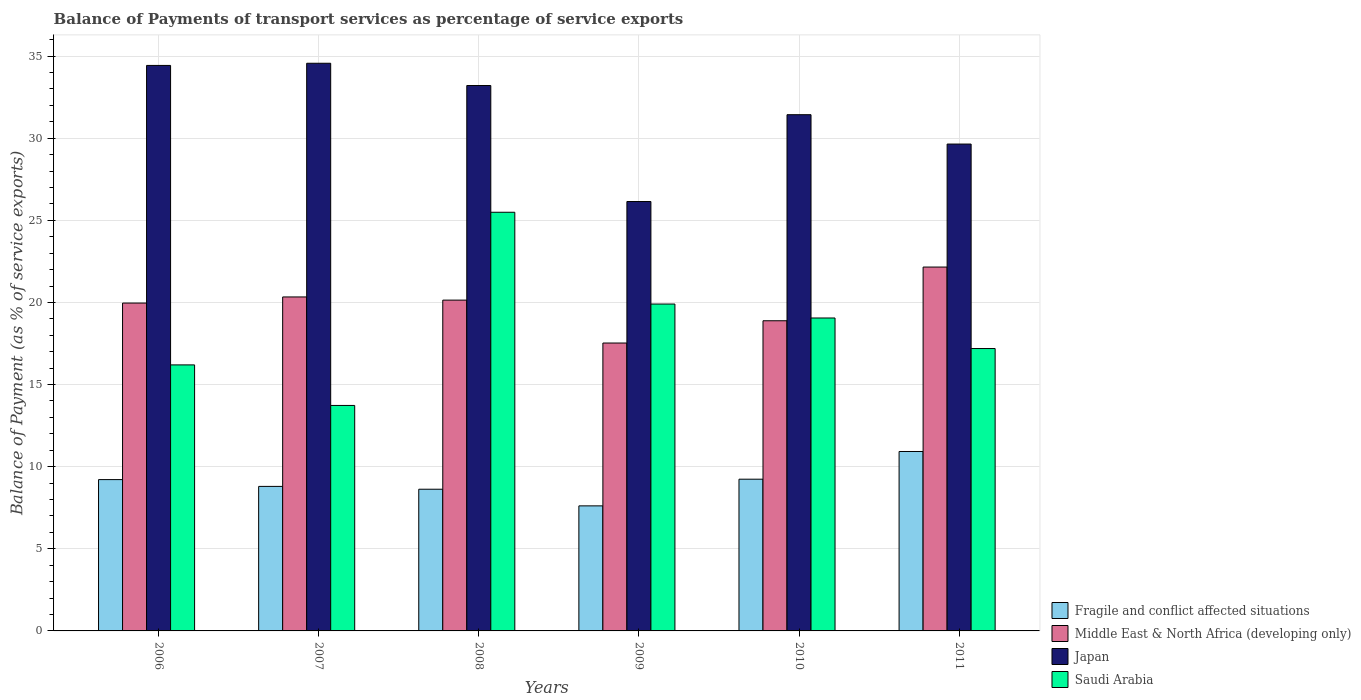How many groups of bars are there?
Offer a very short reply. 6. Are the number of bars per tick equal to the number of legend labels?
Ensure brevity in your answer.  Yes. How many bars are there on the 2nd tick from the right?
Offer a terse response. 4. What is the balance of payments of transport services in Saudi Arabia in 2007?
Your answer should be very brief. 13.73. Across all years, what is the maximum balance of payments of transport services in Japan?
Your answer should be compact. 34.56. Across all years, what is the minimum balance of payments of transport services in Fragile and conflict affected situations?
Your answer should be compact. 7.61. In which year was the balance of payments of transport services in Middle East & North Africa (developing only) minimum?
Offer a very short reply. 2009. What is the total balance of payments of transport services in Middle East & North Africa (developing only) in the graph?
Keep it short and to the point. 119. What is the difference between the balance of payments of transport services in Fragile and conflict affected situations in 2009 and that in 2010?
Keep it short and to the point. -1.62. What is the difference between the balance of payments of transport services in Saudi Arabia in 2011 and the balance of payments of transport services in Fragile and conflict affected situations in 2006?
Make the answer very short. 7.98. What is the average balance of payments of transport services in Saudi Arabia per year?
Keep it short and to the point. 18.59. In the year 2011, what is the difference between the balance of payments of transport services in Middle East & North Africa (developing only) and balance of payments of transport services in Japan?
Your answer should be very brief. -7.49. In how many years, is the balance of payments of transport services in Middle East & North Africa (developing only) greater than 35 %?
Provide a short and direct response. 0. What is the ratio of the balance of payments of transport services in Middle East & North Africa (developing only) in 2007 to that in 2009?
Your response must be concise. 1.16. Is the difference between the balance of payments of transport services in Middle East & North Africa (developing only) in 2006 and 2009 greater than the difference between the balance of payments of transport services in Japan in 2006 and 2009?
Your answer should be very brief. No. What is the difference between the highest and the second highest balance of payments of transport services in Fragile and conflict affected situations?
Give a very brief answer. 1.69. What is the difference between the highest and the lowest balance of payments of transport services in Saudi Arabia?
Ensure brevity in your answer.  11.76. In how many years, is the balance of payments of transport services in Fragile and conflict affected situations greater than the average balance of payments of transport services in Fragile and conflict affected situations taken over all years?
Your answer should be very brief. 3. Is the sum of the balance of payments of transport services in Middle East & North Africa (developing only) in 2007 and 2008 greater than the maximum balance of payments of transport services in Saudi Arabia across all years?
Offer a terse response. Yes. What does the 1st bar from the right in 2010 represents?
Offer a terse response. Saudi Arabia. Is it the case that in every year, the sum of the balance of payments of transport services in Saudi Arabia and balance of payments of transport services in Middle East & North Africa (developing only) is greater than the balance of payments of transport services in Fragile and conflict affected situations?
Provide a succinct answer. Yes. How many bars are there?
Your answer should be compact. 24. Are all the bars in the graph horizontal?
Keep it short and to the point. No. What is the difference between two consecutive major ticks on the Y-axis?
Your response must be concise. 5. Does the graph contain grids?
Provide a succinct answer. Yes. How many legend labels are there?
Give a very brief answer. 4. What is the title of the graph?
Offer a very short reply. Balance of Payments of transport services as percentage of service exports. What is the label or title of the Y-axis?
Ensure brevity in your answer.  Balance of Payment (as % of service exports). What is the Balance of Payment (as % of service exports) of Fragile and conflict affected situations in 2006?
Your answer should be compact. 9.21. What is the Balance of Payment (as % of service exports) of Middle East & North Africa (developing only) in 2006?
Your answer should be compact. 19.96. What is the Balance of Payment (as % of service exports) of Japan in 2006?
Your answer should be compact. 34.43. What is the Balance of Payment (as % of service exports) of Saudi Arabia in 2006?
Make the answer very short. 16.2. What is the Balance of Payment (as % of service exports) of Fragile and conflict affected situations in 2007?
Provide a succinct answer. 8.8. What is the Balance of Payment (as % of service exports) in Middle East & North Africa (developing only) in 2007?
Your answer should be very brief. 20.33. What is the Balance of Payment (as % of service exports) of Japan in 2007?
Provide a short and direct response. 34.56. What is the Balance of Payment (as % of service exports) of Saudi Arabia in 2007?
Offer a terse response. 13.73. What is the Balance of Payment (as % of service exports) of Fragile and conflict affected situations in 2008?
Your response must be concise. 8.63. What is the Balance of Payment (as % of service exports) in Middle East & North Africa (developing only) in 2008?
Ensure brevity in your answer.  20.14. What is the Balance of Payment (as % of service exports) in Japan in 2008?
Provide a short and direct response. 33.21. What is the Balance of Payment (as % of service exports) of Saudi Arabia in 2008?
Offer a very short reply. 25.49. What is the Balance of Payment (as % of service exports) in Fragile and conflict affected situations in 2009?
Keep it short and to the point. 7.61. What is the Balance of Payment (as % of service exports) in Middle East & North Africa (developing only) in 2009?
Your answer should be very brief. 17.53. What is the Balance of Payment (as % of service exports) of Japan in 2009?
Your response must be concise. 26.14. What is the Balance of Payment (as % of service exports) of Saudi Arabia in 2009?
Your response must be concise. 19.9. What is the Balance of Payment (as % of service exports) of Fragile and conflict affected situations in 2010?
Keep it short and to the point. 9.24. What is the Balance of Payment (as % of service exports) of Middle East & North Africa (developing only) in 2010?
Make the answer very short. 18.88. What is the Balance of Payment (as % of service exports) in Japan in 2010?
Offer a terse response. 31.43. What is the Balance of Payment (as % of service exports) of Saudi Arabia in 2010?
Provide a short and direct response. 19.05. What is the Balance of Payment (as % of service exports) in Fragile and conflict affected situations in 2011?
Ensure brevity in your answer.  10.92. What is the Balance of Payment (as % of service exports) in Middle East & North Africa (developing only) in 2011?
Ensure brevity in your answer.  22.15. What is the Balance of Payment (as % of service exports) in Japan in 2011?
Ensure brevity in your answer.  29.64. What is the Balance of Payment (as % of service exports) of Saudi Arabia in 2011?
Offer a terse response. 17.19. Across all years, what is the maximum Balance of Payment (as % of service exports) of Fragile and conflict affected situations?
Your answer should be compact. 10.92. Across all years, what is the maximum Balance of Payment (as % of service exports) of Middle East & North Africa (developing only)?
Keep it short and to the point. 22.15. Across all years, what is the maximum Balance of Payment (as % of service exports) in Japan?
Your answer should be very brief. 34.56. Across all years, what is the maximum Balance of Payment (as % of service exports) of Saudi Arabia?
Offer a terse response. 25.49. Across all years, what is the minimum Balance of Payment (as % of service exports) in Fragile and conflict affected situations?
Make the answer very short. 7.61. Across all years, what is the minimum Balance of Payment (as % of service exports) in Middle East & North Africa (developing only)?
Provide a short and direct response. 17.53. Across all years, what is the minimum Balance of Payment (as % of service exports) in Japan?
Your response must be concise. 26.14. Across all years, what is the minimum Balance of Payment (as % of service exports) of Saudi Arabia?
Your answer should be very brief. 13.73. What is the total Balance of Payment (as % of service exports) in Fragile and conflict affected situations in the graph?
Your answer should be compact. 54.42. What is the total Balance of Payment (as % of service exports) of Middle East & North Africa (developing only) in the graph?
Your answer should be compact. 119. What is the total Balance of Payment (as % of service exports) of Japan in the graph?
Your answer should be compact. 189.42. What is the total Balance of Payment (as % of service exports) in Saudi Arabia in the graph?
Your answer should be very brief. 111.56. What is the difference between the Balance of Payment (as % of service exports) in Fragile and conflict affected situations in 2006 and that in 2007?
Your response must be concise. 0.41. What is the difference between the Balance of Payment (as % of service exports) in Middle East & North Africa (developing only) in 2006 and that in 2007?
Keep it short and to the point. -0.37. What is the difference between the Balance of Payment (as % of service exports) of Japan in 2006 and that in 2007?
Provide a short and direct response. -0.13. What is the difference between the Balance of Payment (as % of service exports) of Saudi Arabia in 2006 and that in 2007?
Your answer should be compact. 2.47. What is the difference between the Balance of Payment (as % of service exports) in Fragile and conflict affected situations in 2006 and that in 2008?
Your answer should be very brief. 0.59. What is the difference between the Balance of Payment (as % of service exports) of Middle East & North Africa (developing only) in 2006 and that in 2008?
Make the answer very short. -0.18. What is the difference between the Balance of Payment (as % of service exports) of Japan in 2006 and that in 2008?
Your answer should be compact. 1.22. What is the difference between the Balance of Payment (as % of service exports) in Saudi Arabia in 2006 and that in 2008?
Make the answer very short. -9.29. What is the difference between the Balance of Payment (as % of service exports) of Fragile and conflict affected situations in 2006 and that in 2009?
Provide a short and direct response. 1.6. What is the difference between the Balance of Payment (as % of service exports) in Middle East & North Africa (developing only) in 2006 and that in 2009?
Your answer should be compact. 2.43. What is the difference between the Balance of Payment (as % of service exports) in Japan in 2006 and that in 2009?
Provide a short and direct response. 8.29. What is the difference between the Balance of Payment (as % of service exports) in Saudi Arabia in 2006 and that in 2009?
Provide a succinct answer. -3.71. What is the difference between the Balance of Payment (as % of service exports) of Fragile and conflict affected situations in 2006 and that in 2010?
Keep it short and to the point. -0.02. What is the difference between the Balance of Payment (as % of service exports) in Middle East & North Africa (developing only) in 2006 and that in 2010?
Offer a terse response. 1.08. What is the difference between the Balance of Payment (as % of service exports) of Japan in 2006 and that in 2010?
Keep it short and to the point. 3. What is the difference between the Balance of Payment (as % of service exports) of Saudi Arabia in 2006 and that in 2010?
Give a very brief answer. -2.86. What is the difference between the Balance of Payment (as % of service exports) of Fragile and conflict affected situations in 2006 and that in 2011?
Keep it short and to the point. -1.71. What is the difference between the Balance of Payment (as % of service exports) of Middle East & North Africa (developing only) in 2006 and that in 2011?
Make the answer very short. -2.19. What is the difference between the Balance of Payment (as % of service exports) of Japan in 2006 and that in 2011?
Offer a terse response. 4.79. What is the difference between the Balance of Payment (as % of service exports) of Saudi Arabia in 2006 and that in 2011?
Offer a very short reply. -1. What is the difference between the Balance of Payment (as % of service exports) in Fragile and conflict affected situations in 2007 and that in 2008?
Ensure brevity in your answer.  0.17. What is the difference between the Balance of Payment (as % of service exports) in Middle East & North Africa (developing only) in 2007 and that in 2008?
Provide a short and direct response. 0.19. What is the difference between the Balance of Payment (as % of service exports) of Japan in 2007 and that in 2008?
Your response must be concise. 1.36. What is the difference between the Balance of Payment (as % of service exports) in Saudi Arabia in 2007 and that in 2008?
Your answer should be compact. -11.76. What is the difference between the Balance of Payment (as % of service exports) in Fragile and conflict affected situations in 2007 and that in 2009?
Offer a very short reply. 1.19. What is the difference between the Balance of Payment (as % of service exports) of Middle East & North Africa (developing only) in 2007 and that in 2009?
Provide a short and direct response. 2.81. What is the difference between the Balance of Payment (as % of service exports) in Japan in 2007 and that in 2009?
Provide a succinct answer. 8.42. What is the difference between the Balance of Payment (as % of service exports) of Saudi Arabia in 2007 and that in 2009?
Offer a very short reply. -6.17. What is the difference between the Balance of Payment (as % of service exports) of Fragile and conflict affected situations in 2007 and that in 2010?
Your answer should be compact. -0.44. What is the difference between the Balance of Payment (as % of service exports) in Middle East & North Africa (developing only) in 2007 and that in 2010?
Your response must be concise. 1.45. What is the difference between the Balance of Payment (as % of service exports) of Japan in 2007 and that in 2010?
Ensure brevity in your answer.  3.13. What is the difference between the Balance of Payment (as % of service exports) in Saudi Arabia in 2007 and that in 2010?
Your answer should be very brief. -5.33. What is the difference between the Balance of Payment (as % of service exports) of Fragile and conflict affected situations in 2007 and that in 2011?
Your answer should be compact. -2.13. What is the difference between the Balance of Payment (as % of service exports) of Middle East & North Africa (developing only) in 2007 and that in 2011?
Offer a very short reply. -1.82. What is the difference between the Balance of Payment (as % of service exports) of Japan in 2007 and that in 2011?
Your answer should be very brief. 4.92. What is the difference between the Balance of Payment (as % of service exports) of Saudi Arabia in 2007 and that in 2011?
Offer a terse response. -3.46. What is the difference between the Balance of Payment (as % of service exports) in Fragile and conflict affected situations in 2008 and that in 2009?
Keep it short and to the point. 1.01. What is the difference between the Balance of Payment (as % of service exports) of Middle East & North Africa (developing only) in 2008 and that in 2009?
Ensure brevity in your answer.  2.61. What is the difference between the Balance of Payment (as % of service exports) in Japan in 2008 and that in 2009?
Your answer should be compact. 7.06. What is the difference between the Balance of Payment (as % of service exports) in Saudi Arabia in 2008 and that in 2009?
Offer a terse response. 5.59. What is the difference between the Balance of Payment (as % of service exports) in Fragile and conflict affected situations in 2008 and that in 2010?
Offer a very short reply. -0.61. What is the difference between the Balance of Payment (as % of service exports) of Middle East & North Africa (developing only) in 2008 and that in 2010?
Offer a very short reply. 1.26. What is the difference between the Balance of Payment (as % of service exports) of Japan in 2008 and that in 2010?
Offer a terse response. 1.78. What is the difference between the Balance of Payment (as % of service exports) in Saudi Arabia in 2008 and that in 2010?
Your answer should be very brief. 6.44. What is the difference between the Balance of Payment (as % of service exports) of Fragile and conflict affected situations in 2008 and that in 2011?
Keep it short and to the point. -2.3. What is the difference between the Balance of Payment (as % of service exports) of Middle East & North Africa (developing only) in 2008 and that in 2011?
Keep it short and to the point. -2.01. What is the difference between the Balance of Payment (as % of service exports) in Japan in 2008 and that in 2011?
Ensure brevity in your answer.  3.56. What is the difference between the Balance of Payment (as % of service exports) of Saudi Arabia in 2008 and that in 2011?
Your response must be concise. 8.3. What is the difference between the Balance of Payment (as % of service exports) of Fragile and conflict affected situations in 2009 and that in 2010?
Your answer should be very brief. -1.62. What is the difference between the Balance of Payment (as % of service exports) of Middle East & North Africa (developing only) in 2009 and that in 2010?
Your answer should be compact. -1.36. What is the difference between the Balance of Payment (as % of service exports) of Japan in 2009 and that in 2010?
Provide a short and direct response. -5.29. What is the difference between the Balance of Payment (as % of service exports) in Saudi Arabia in 2009 and that in 2010?
Your response must be concise. 0.85. What is the difference between the Balance of Payment (as % of service exports) of Fragile and conflict affected situations in 2009 and that in 2011?
Give a very brief answer. -3.31. What is the difference between the Balance of Payment (as % of service exports) in Middle East & North Africa (developing only) in 2009 and that in 2011?
Offer a very short reply. -4.63. What is the difference between the Balance of Payment (as % of service exports) in Japan in 2009 and that in 2011?
Your answer should be very brief. -3.5. What is the difference between the Balance of Payment (as % of service exports) in Saudi Arabia in 2009 and that in 2011?
Provide a short and direct response. 2.71. What is the difference between the Balance of Payment (as % of service exports) of Fragile and conflict affected situations in 2010 and that in 2011?
Keep it short and to the point. -1.69. What is the difference between the Balance of Payment (as % of service exports) of Middle East & North Africa (developing only) in 2010 and that in 2011?
Provide a short and direct response. -3.27. What is the difference between the Balance of Payment (as % of service exports) of Japan in 2010 and that in 2011?
Provide a succinct answer. 1.79. What is the difference between the Balance of Payment (as % of service exports) in Saudi Arabia in 2010 and that in 2011?
Provide a short and direct response. 1.86. What is the difference between the Balance of Payment (as % of service exports) in Fragile and conflict affected situations in 2006 and the Balance of Payment (as % of service exports) in Middle East & North Africa (developing only) in 2007?
Give a very brief answer. -11.12. What is the difference between the Balance of Payment (as % of service exports) in Fragile and conflict affected situations in 2006 and the Balance of Payment (as % of service exports) in Japan in 2007?
Make the answer very short. -25.35. What is the difference between the Balance of Payment (as % of service exports) in Fragile and conflict affected situations in 2006 and the Balance of Payment (as % of service exports) in Saudi Arabia in 2007?
Provide a short and direct response. -4.51. What is the difference between the Balance of Payment (as % of service exports) in Middle East & North Africa (developing only) in 2006 and the Balance of Payment (as % of service exports) in Japan in 2007?
Provide a succinct answer. -14.6. What is the difference between the Balance of Payment (as % of service exports) of Middle East & North Africa (developing only) in 2006 and the Balance of Payment (as % of service exports) of Saudi Arabia in 2007?
Keep it short and to the point. 6.23. What is the difference between the Balance of Payment (as % of service exports) in Japan in 2006 and the Balance of Payment (as % of service exports) in Saudi Arabia in 2007?
Make the answer very short. 20.7. What is the difference between the Balance of Payment (as % of service exports) in Fragile and conflict affected situations in 2006 and the Balance of Payment (as % of service exports) in Middle East & North Africa (developing only) in 2008?
Provide a succinct answer. -10.93. What is the difference between the Balance of Payment (as % of service exports) in Fragile and conflict affected situations in 2006 and the Balance of Payment (as % of service exports) in Japan in 2008?
Offer a terse response. -23.99. What is the difference between the Balance of Payment (as % of service exports) of Fragile and conflict affected situations in 2006 and the Balance of Payment (as % of service exports) of Saudi Arabia in 2008?
Offer a terse response. -16.28. What is the difference between the Balance of Payment (as % of service exports) of Middle East & North Africa (developing only) in 2006 and the Balance of Payment (as % of service exports) of Japan in 2008?
Your answer should be compact. -13.24. What is the difference between the Balance of Payment (as % of service exports) in Middle East & North Africa (developing only) in 2006 and the Balance of Payment (as % of service exports) in Saudi Arabia in 2008?
Keep it short and to the point. -5.53. What is the difference between the Balance of Payment (as % of service exports) of Japan in 2006 and the Balance of Payment (as % of service exports) of Saudi Arabia in 2008?
Provide a short and direct response. 8.94. What is the difference between the Balance of Payment (as % of service exports) in Fragile and conflict affected situations in 2006 and the Balance of Payment (as % of service exports) in Middle East & North Africa (developing only) in 2009?
Offer a terse response. -8.32. What is the difference between the Balance of Payment (as % of service exports) of Fragile and conflict affected situations in 2006 and the Balance of Payment (as % of service exports) of Japan in 2009?
Make the answer very short. -16.93. What is the difference between the Balance of Payment (as % of service exports) of Fragile and conflict affected situations in 2006 and the Balance of Payment (as % of service exports) of Saudi Arabia in 2009?
Offer a terse response. -10.69. What is the difference between the Balance of Payment (as % of service exports) of Middle East & North Africa (developing only) in 2006 and the Balance of Payment (as % of service exports) of Japan in 2009?
Your answer should be compact. -6.18. What is the difference between the Balance of Payment (as % of service exports) in Middle East & North Africa (developing only) in 2006 and the Balance of Payment (as % of service exports) in Saudi Arabia in 2009?
Your response must be concise. 0.06. What is the difference between the Balance of Payment (as % of service exports) in Japan in 2006 and the Balance of Payment (as % of service exports) in Saudi Arabia in 2009?
Ensure brevity in your answer.  14.53. What is the difference between the Balance of Payment (as % of service exports) in Fragile and conflict affected situations in 2006 and the Balance of Payment (as % of service exports) in Middle East & North Africa (developing only) in 2010?
Ensure brevity in your answer.  -9.67. What is the difference between the Balance of Payment (as % of service exports) in Fragile and conflict affected situations in 2006 and the Balance of Payment (as % of service exports) in Japan in 2010?
Offer a very short reply. -22.22. What is the difference between the Balance of Payment (as % of service exports) of Fragile and conflict affected situations in 2006 and the Balance of Payment (as % of service exports) of Saudi Arabia in 2010?
Make the answer very short. -9.84. What is the difference between the Balance of Payment (as % of service exports) in Middle East & North Africa (developing only) in 2006 and the Balance of Payment (as % of service exports) in Japan in 2010?
Offer a very short reply. -11.47. What is the difference between the Balance of Payment (as % of service exports) in Japan in 2006 and the Balance of Payment (as % of service exports) in Saudi Arabia in 2010?
Keep it short and to the point. 15.38. What is the difference between the Balance of Payment (as % of service exports) of Fragile and conflict affected situations in 2006 and the Balance of Payment (as % of service exports) of Middle East & North Africa (developing only) in 2011?
Make the answer very short. -12.94. What is the difference between the Balance of Payment (as % of service exports) of Fragile and conflict affected situations in 2006 and the Balance of Payment (as % of service exports) of Japan in 2011?
Offer a terse response. -20.43. What is the difference between the Balance of Payment (as % of service exports) of Fragile and conflict affected situations in 2006 and the Balance of Payment (as % of service exports) of Saudi Arabia in 2011?
Provide a succinct answer. -7.98. What is the difference between the Balance of Payment (as % of service exports) of Middle East & North Africa (developing only) in 2006 and the Balance of Payment (as % of service exports) of Japan in 2011?
Make the answer very short. -9.68. What is the difference between the Balance of Payment (as % of service exports) of Middle East & North Africa (developing only) in 2006 and the Balance of Payment (as % of service exports) of Saudi Arabia in 2011?
Offer a very short reply. 2.77. What is the difference between the Balance of Payment (as % of service exports) of Japan in 2006 and the Balance of Payment (as % of service exports) of Saudi Arabia in 2011?
Your answer should be very brief. 17.24. What is the difference between the Balance of Payment (as % of service exports) of Fragile and conflict affected situations in 2007 and the Balance of Payment (as % of service exports) of Middle East & North Africa (developing only) in 2008?
Your response must be concise. -11.34. What is the difference between the Balance of Payment (as % of service exports) of Fragile and conflict affected situations in 2007 and the Balance of Payment (as % of service exports) of Japan in 2008?
Offer a very short reply. -24.41. What is the difference between the Balance of Payment (as % of service exports) in Fragile and conflict affected situations in 2007 and the Balance of Payment (as % of service exports) in Saudi Arabia in 2008?
Provide a succinct answer. -16.69. What is the difference between the Balance of Payment (as % of service exports) of Middle East & North Africa (developing only) in 2007 and the Balance of Payment (as % of service exports) of Japan in 2008?
Make the answer very short. -12.87. What is the difference between the Balance of Payment (as % of service exports) in Middle East & North Africa (developing only) in 2007 and the Balance of Payment (as % of service exports) in Saudi Arabia in 2008?
Provide a short and direct response. -5.16. What is the difference between the Balance of Payment (as % of service exports) of Japan in 2007 and the Balance of Payment (as % of service exports) of Saudi Arabia in 2008?
Your answer should be very brief. 9.07. What is the difference between the Balance of Payment (as % of service exports) in Fragile and conflict affected situations in 2007 and the Balance of Payment (as % of service exports) in Middle East & North Africa (developing only) in 2009?
Your response must be concise. -8.73. What is the difference between the Balance of Payment (as % of service exports) in Fragile and conflict affected situations in 2007 and the Balance of Payment (as % of service exports) in Japan in 2009?
Offer a very short reply. -17.34. What is the difference between the Balance of Payment (as % of service exports) of Fragile and conflict affected situations in 2007 and the Balance of Payment (as % of service exports) of Saudi Arabia in 2009?
Your answer should be compact. -11.1. What is the difference between the Balance of Payment (as % of service exports) in Middle East & North Africa (developing only) in 2007 and the Balance of Payment (as % of service exports) in Japan in 2009?
Your answer should be compact. -5.81. What is the difference between the Balance of Payment (as % of service exports) of Middle East & North Africa (developing only) in 2007 and the Balance of Payment (as % of service exports) of Saudi Arabia in 2009?
Your answer should be very brief. 0.43. What is the difference between the Balance of Payment (as % of service exports) of Japan in 2007 and the Balance of Payment (as % of service exports) of Saudi Arabia in 2009?
Your answer should be very brief. 14.66. What is the difference between the Balance of Payment (as % of service exports) of Fragile and conflict affected situations in 2007 and the Balance of Payment (as % of service exports) of Middle East & North Africa (developing only) in 2010?
Make the answer very short. -10.09. What is the difference between the Balance of Payment (as % of service exports) of Fragile and conflict affected situations in 2007 and the Balance of Payment (as % of service exports) of Japan in 2010?
Give a very brief answer. -22.63. What is the difference between the Balance of Payment (as % of service exports) in Fragile and conflict affected situations in 2007 and the Balance of Payment (as % of service exports) in Saudi Arabia in 2010?
Offer a very short reply. -10.25. What is the difference between the Balance of Payment (as % of service exports) of Middle East & North Africa (developing only) in 2007 and the Balance of Payment (as % of service exports) of Japan in 2010?
Your answer should be compact. -11.1. What is the difference between the Balance of Payment (as % of service exports) of Middle East & North Africa (developing only) in 2007 and the Balance of Payment (as % of service exports) of Saudi Arabia in 2010?
Keep it short and to the point. 1.28. What is the difference between the Balance of Payment (as % of service exports) of Japan in 2007 and the Balance of Payment (as % of service exports) of Saudi Arabia in 2010?
Your answer should be very brief. 15.51. What is the difference between the Balance of Payment (as % of service exports) in Fragile and conflict affected situations in 2007 and the Balance of Payment (as % of service exports) in Middle East & North Africa (developing only) in 2011?
Your response must be concise. -13.36. What is the difference between the Balance of Payment (as % of service exports) in Fragile and conflict affected situations in 2007 and the Balance of Payment (as % of service exports) in Japan in 2011?
Provide a short and direct response. -20.84. What is the difference between the Balance of Payment (as % of service exports) of Fragile and conflict affected situations in 2007 and the Balance of Payment (as % of service exports) of Saudi Arabia in 2011?
Ensure brevity in your answer.  -8.39. What is the difference between the Balance of Payment (as % of service exports) of Middle East & North Africa (developing only) in 2007 and the Balance of Payment (as % of service exports) of Japan in 2011?
Provide a succinct answer. -9.31. What is the difference between the Balance of Payment (as % of service exports) in Middle East & North Africa (developing only) in 2007 and the Balance of Payment (as % of service exports) in Saudi Arabia in 2011?
Your answer should be compact. 3.14. What is the difference between the Balance of Payment (as % of service exports) in Japan in 2007 and the Balance of Payment (as % of service exports) in Saudi Arabia in 2011?
Your response must be concise. 17.37. What is the difference between the Balance of Payment (as % of service exports) in Fragile and conflict affected situations in 2008 and the Balance of Payment (as % of service exports) in Middle East & North Africa (developing only) in 2009?
Your answer should be compact. -8.9. What is the difference between the Balance of Payment (as % of service exports) of Fragile and conflict affected situations in 2008 and the Balance of Payment (as % of service exports) of Japan in 2009?
Keep it short and to the point. -17.52. What is the difference between the Balance of Payment (as % of service exports) of Fragile and conflict affected situations in 2008 and the Balance of Payment (as % of service exports) of Saudi Arabia in 2009?
Your answer should be compact. -11.27. What is the difference between the Balance of Payment (as % of service exports) of Middle East & North Africa (developing only) in 2008 and the Balance of Payment (as % of service exports) of Japan in 2009?
Make the answer very short. -6. What is the difference between the Balance of Payment (as % of service exports) in Middle East & North Africa (developing only) in 2008 and the Balance of Payment (as % of service exports) in Saudi Arabia in 2009?
Give a very brief answer. 0.24. What is the difference between the Balance of Payment (as % of service exports) of Japan in 2008 and the Balance of Payment (as % of service exports) of Saudi Arabia in 2009?
Your answer should be very brief. 13.3. What is the difference between the Balance of Payment (as % of service exports) of Fragile and conflict affected situations in 2008 and the Balance of Payment (as % of service exports) of Middle East & North Africa (developing only) in 2010?
Keep it short and to the point. -10.26. What is the difference between the Balance of Payment (as % of service exports) in Fragile and conflict affected situations in 2008 and the Balance of Payment (as % of service exports) in Japan in 2010?
Keep it short and to the point. -22.8. What is the difference between the Balance of Payment (as % of service exports) in Fragile and conflict affected situations in 2008 and the Balance of Payment (as % of service exports) in Saudi Arabia in 2010?
Provide a succinct answer. -10.43. What is the difference between the Balance of Payment (as % of service exports) of Middle East & North Africa (developing only) in 2008 and the Balance of Payment (as % of service exports) of Japan in 2010?
Your answer should be compact. -11.29. What is the difference between the Balance of Payment (as % of service exports) of Middle East & North Africa (developing only) in 2008 and the Balance of Payment (as % of service exports) of Saudi Arabia in 2010?
Keep it short and to the point. 1.09. What is the difference between the Balance of Payment (as % of service exports) in Japan in 2008 and the Balance of Payment (as % of service exports) in Saudi Arabia in 2010?
Offer a terse response. 14.15. What is the difference between the Balance of Payment (as % of service exports) in Fragile and conflict affected situations in 2008 and the Balance of Payment (as % of service exports) in Middle East & North Africa (developing only) in 2011?
Provide a short and direct response. -13.53. What is the difference between the Balance of Payment (as % of service exports) of Fragile and conflict affected situations in 2008 and the Balance of Payment (as % of service exports) of Japan in 2011?
Your answer should be compact. -21.02. What is the difference between the Balance of Payment (as % of service exports) in Fragile and conflict affected situations in 2008 and the Balance of Payment (as % of service exports) in Saudi Arabia in 2011?
Provide a short and direct response. -8.56. What is the difference between the Balance of Payment (as % of service exports) of Middle East & North Africa (developing only) in 2008 and the Balance of Payment (as % of service exports) of Japan in 2011?
Offer a terse response. -9.5. What is the difference between the Balance of Payment (as % of service exports) of Middle East & North Africa (developing only) in 2008 and the Balance of Payment (as % of service exports) of Saudi Arabia in 2011?
Your answer should be very brief. 2.95. What is the difference between the Balance of Payment (as % of service exports) of Japan in 2008 and the Balance of Payment (as % of service exports) of Saudi Arabia in 2011?
Offer a terse response. 16.01. What is the difference between the Balance of Payment (as % of service exports) of Fragile and conflict affected situations in 2009 and the Balance of Payment (as % of service exports) of Middle East & North Africa (developing only) in 2010?
Make the answer very short. -11.27. What is the difference between the Balance of Payment (as % of service exports) in Fragile and conflict affected situations in 2009 and the Balance of Payment (as % of service exports) in Japan in 2010?
Your answer should be compact. -23.82. What is the difference between the Balance of Payment (as % of service exports) in Fragile and conflict affected situations in 2009 and the Balance of Payment (as % of service exports) in Saudi Arabia in 2010?
Your answer should be very brief. -11.44. What is the difference between the Balance of Payment (as % of service exports) in Middle East & North Africa (developing only) in 2009 and the Balance of Payment (as % of service exports) in Japan in 2010?
Offer a very short reply. -13.9. What is the difference between the Balance of Payment (as % of service exports) of Middle East & North Africa (developing only) in 2009 and the Balance of Payment (as % of service exports) of Saudi Arabia in 2010?
Give a very brief answer. -1.52. What is the difference between the Balance of Payment (as % of service exports) in Japan in 2009 and the Balance of Payment (as % of service exports) in Saudi Arabia in 2010?
Your answer should be very brief. 7.09. What is the difference between the Balance of Payment (as % of service exports) in Fragile and conflict affected situations in 2009 and the Balance of Payment (as % of service exports) in Middle East & North Africa (developing only) in 2011?
Your answer should be compact. -14.54. What is the difference between the Balance of Payment (as % of service exports) of Fragile and conflict affected situations in 2009 and the Balance of Payment (as % of service exports) of Japan in 2011?
Make the answer very short. -22.03. What is the difference between the Balance of Payment (as % of service exports) in Fragile and conflict affected situations in 2009 and the Balance of Payment (as % of service exports) in Saudi Arabia in 2011?
Your answer should be compact. -9.58. What is the difference between the Balance of Payment (as % of service exports) in Middle East & North Africa (developing only) in 2009 and the Balance of Payment (as % of service exports) in Japan in 2011?
Keep it short and to the point. -12.11. What is the difference between the Balance of Payment (as % of service exports) in Middle East & North Africa (developing only) in 2009 and the Balance of Payment (as % of service exports) in Saudi Arabia in 2011?
Make the answer very short. 0.34. What is the difference between the Balance of Payment (as % of service exports) of Japan in 2009 and the Balance of Payment (as % of service exports) of Saudi Arabia in 2011?
Provide a succinct answer. 8.95. What is the difference between the Balance of Payment (as % of service exports) of Fragile and conflict affected situations in 2010 and the Balance of Payment (as % of service exports) of Middle East & North Africa (developing only) in 2011?
Give a very brief answer. -12.92. What is the difference between the Balance of Payment (as % of service exports) in Fragile and conflict affected situations in 2010 and the Balance of Payment (as % of service exports) in Japan in 2011?
Your response must be concise. -20.41. What is the difference between the Balance of Payment (as % of service exports) of Fragile and conflict affected situations in 2010 and the Balance of Payment (as % of service exports) of Saudi Arabia in 2011?
Ensure brevity in your answer.  -7.96. What is the difference between the Balance of Payment (as % of service exports) of Middle East & North Africa (developing only) in 2010 and the Balance of Payment (as % of service exports) of Japan in 2011?
Give a very brief answer. -10.76. What is the difference between the Balance of Payment (as % of service exports) of Middle East & North Africa (developing only) in 2010 and the Balance of Payment (as % of service exports) of Saudi Arabia in 2011?
Offer a terse response. 1.69. What is the difference between the Balance of Payment (as % of service exports) in Japan in 2010 and the Balance of Payment (as % of service exports) in Saudi Arabia in 2011?
Offer a terse response. 14.24. What is the average Balance of Payment (as % of service exports) of Fragile and conflict affected situations per year?
Provide a succinct answer. 9.07. What is the average Balance of Payment (as % of service exports) of Middle East & North Africa (developing only) per year?
Provide a short and direct response. 19.83. What is the average Balance of Payment (as % of service exports) of Japan per year?
Keep it short and to the point. 31.57. What is the average Balance of Payment (as % of service exports) in Saudi Arabia per year?
Offer a very short reply. 18.59. In the year 2006, what is the difference between the Balance of Payment (as % of service exports) of Fragile and conflict affected situations and Balance of Payment (as % of service exports) of Middle East & North Africa (developing only)?
Provide a succinct answer. -10.75. In the year 2006, what is the difference between the Balance of Payment (as % of service exports) of Fragile and conflict affected situations and Balance of Payment (as % of service exports) of Japan?
Provide a short and direct response. -25.22. In the year 2006, what is the difference between the Balance of Payment (as % of service exports) of Fragile and conflict affected situations and Balance of Payment (as % of service exports) of Saudi Arabia?
Your response must be concise. -6.98. In the year 2006, what is the difference between the Balance of Payment (as % of service exports) of Middle East & North Africa (developing only) and Balance of Payment (as % of service exports) of Japan?
Your answer should be compact. -14.47. In the year 2006, what is the difference between the Balance of Payment (as % of service exports) in Middle East & North Africa (developing only) and Balance of Payment (as % of service exports) in Saudi Arabia?
Provide a short and direct response. 3.77. In the year 2006, what is the difference between the Balance of Payment (as % of service exports) of Japan and Balance of Payment (as % of service exports) of Saudi Arabia?
Offer a very short reply. 18.23. In the year 2007, what is the difference between the Balance of Payment (as % of service exports) in Fragile and conflict affected situations and Balance of Payment (as % of service exports) in Middle East & North Africa (developing only)?
Offer a terse response. -11.54. In the year 2007, what is the difference between the Balance of Payment (as % of service exports) in Fragile and conflict affected situations and Balance of Payment (as % of service exports) in Japan?
Offer a very short reply. -25.76. In the year 2007, what is the difference between the Balance of Payment (as % of service exports) in Fragile and conflict affected situations and Balance of Payment (as % of service exports) in Saudi Arabia?
Your response must be concise. -4.93. In the year 2007, what is the difference between the Balance of Payment (as % of service exports) in Middle East & North Africa (developing only) and Balance of Payment (as % of service exports) in Japan?
Your response must be concise. -14.23. In the year 2007, what is the difference between the Balance of Payment (as % of service exports) of Middle East & North Africa (developing only) and Balance of Payment (as % of service exports) of Saudi Arabia?
Your response must be concise. 6.61. In the year 2007, what is the difference between the Balance of Payment (as % of service exports) in Japan and Balance of Payment (as % of service exports) in Saudi Arabia?
Offer a very short reply. 20.83. In the year 2008, what is the difference between the Balance of Payment (as % of service exports) in Fragile and conflict affected situations and Balance of Payment (as % of service exports) in Middle East & North Africa (developing only)?
Make the answer very short. -11.51. In the year 2008, what is the difference between the Balance of Payment (as % of service exports) of Fragile and conflict affected situations and Balance of Payment (as % of service exports) of Japan?
Give a very brief answer. -24.58. In the year 2008, what is the difference between the Balance of Payment (as % of service exports) of Fragile and conflict affected situations and Balance of Payment (as % of service exports) of Saudi Arabia?
Ensure brevity in your answer.  -16.86. In the year 2008, what is the difference between the Balance of Payment (as % of service exports) in Middle East & North Africa (developing only) and Balance of Payment (as % of service exports) in Japan?
Offer a very short reply. -13.07. In the year 2008, what is the difference between the Balance of Payment (as % of service exports) of Middle East & North Africa (developing only) and Balance of Payment (as % of service exports) of Saudi Arabia?
Give a very brief answer. -5.35. In the year 2008, what is the difference between the Balance of Payment (as % of service exports) in Japan and Balance of Payment (as % of service exports) in Saudi Arabia?
Ensure brevity in your answer.  7.72. In the year 2009, what is the difference between the Balance of Payment (as % of service exports) of Fragile and conflict affected situations and Balance of Payment (as % of service exports) of Middle East & North Africa (developing only)?
Your answer should be compact. -9.92. In the year 2009, what is the difference between the Balance of Payment (as % of service exports) in Fragile and conflict affected situations and Balance of Payment (as % of service exports) in Japan?
Your response must be concise. -18.53. In the year 2009, what is the difference between the Balance of Payment (as % of service exports) of Fragile and conflict affected situations and Balance of Payment (as % of service exports) of Saudi Arabia?
Keep it short and to the point. -12.29. In the year 2009, what is the difference between the Balance of Payment (as % of service exports) in Middle East & North Africa (developing only) and Balance of Payment (as % of service exports) in Japan?
Offer a terse response. -8.62. In the year 2009, what is the difference between the Balance of Payment (as % of service exports) of Middle East & North Africa (developing only) and Balance of Payment (as % of service exports) of Saudi Arabia?
Offer a terse response. -2.37. In the year 2009, what is the difference between the Balance of Payment (as % of service exports) of Japan and Balance of Payment (as % of service exports) of Saudi Arabia?
Ensure brevity in your answer.  6.24. In the year 2010, what is the difference between the Balance of Payment (as % of service exports) of Fragile and conflict affected situations and Balance of Payment (as % of service exports) of Middle East & North Africa (developing only)?
Offer a terse response. -9.65. In the year 2010, what is the difference between the Balance of Payment (as % of service exports) in Fragile and conflict affected situations and Balance of Payment (as % of service exports) in Japan?
Offer a terse response. -22.19. In the year 2010, what is the difference between the Balance of Payment (as % of service exports) of Fragile and conflict affected situations and Balance of Payment (as % of service exports) of Saudi Arabia?
Offer a terse response. -9.82. In the year 2010, what is the difference between the Balance of Payment (as % of service exports) of Middle East & North Africa (developing only) and Balance of Payment (as % of service exports) of Japan?
Make the answer very short. -12.55. In the year 2010, what is the difference between the Balance of Payment (as % of service exports) of Middle East & North Africa (developing only) and Balance of Payment (as % of service exports) of Saudi Arabia?
Your response must be concise. -0.17. In the year 2010, what is the difference between the Balance of Payment (as % of service exports) in Japan and Balance of Payment (as % of service exports) in Saudi Arabia?
Offer a very short reply. 12.38. In the year 2011, what is the difference between the Balance of Payment (as % of service exports) of Fragile and conflict affected situations and Balance of Payment (as % of service exports) of Middle East & North Africa (developing only)?
Give a very brief answer. -11.23. In the year 2011, what is the difference between the Balance of Payment (as % of service exports) in Fragile and conflict affected situations and Balance of Payment (as % of service exports) in Japan?
Offer a very short reply. -18.72. In the year 2011, what is the difference between the Balance of Payment (as % of service exports) of Fragile and conflict affected situations and Balance of Payment (as % of service exports) of Saudi Arabia?
Make the answer very short. -6.27. In the year 2011, what is the difference between the Balance of Payment (as % of service exports) of Middle East & North Africa (developing only) and Balance of Payment (as % of service exports) of Japan?
Your answer should be compact. -7.49. In the year 2011, what is the difference between the Balance of Payment (as % of service exports) in Middle East & North Africa (developing only) and Balance of Payment (as % of service exports) in Saudi Arabia?
Your answer should be very brief. 4.96. In the year 2011, what is the difference between the Balance of Payment (as % of service exports) of Japan and Balance of Payment (as % of service exports) of Saudi Arabia?
Keep it short and to the point. 12.45. What is the ratio of the Balance of Payment (as % of service exports) in Fragile and conflict affected situations in 2006 to that in 2007?
Offer a very short reply. 1.05. What is the ratio of the Balance of Payment (as % of service exports) in Middle East & North Africa (developing only) in 2006 to that in 2007?
Provide a short and direct response. 0.98. What is the ratio of the Balance of Payment (as % of service exports) in Japan in 2006 to that in 2007?
Give a very brief answer. 1. What is the ratio of the Balance of Payment (as % of service exports) of Saudi Arabia in 2006 to that in 2007?
Ensure brevity in your answer.  1.18. What is the ratio of the Balance of Payment (as % of service exports) in Fragile and conflict affected situations in 2006 to that in 2008?
Offer a very short reply. 1.07. What is the ratio of the Balance of Payment (as % of service exports) in Middle East & North Africa (developing only) in 2006 to that in 2008?
Offer a very short reply. 0.99. What is the ratio of the Balance of Payment (as % of service exports) of Japan in 2006 to that in 2008?
Provide a succinct answer. 1.04. What is the ratio of the Balance of Payment (as % of service exports) in Saudi Arabia in 2006 to that in 2008?
Your answer should be compact. 0.64. What is the ratio of the Balance of Payment (as % of service exports) of Fragile and conflict affected situations in 2006 to that in 2009?
Your response must be concise. 1.21. What is the ratio of the Balance of Payment (as % of service exports) of Middle East & North Africa (developing only) in 2006 to that in 2009?
Offer a terse response. 1.14. What is the ratio of the Balance of Payment (as % of service exports) in Japan in 2006 to that in 2009?
Offer a terse response. 1.32. What is the ratio of the Balance of Payment (as % of service exports) of Saudi Arabia in 2006 to that in 2009?
Provide a short and direct response. 0.81. What is the ratio of the Balance of Payment (as % of service exports) in Fragile and conflict affected situations in 2006 to that in 2010?
Offer a terse response. 1. What is the ratio of the Balance of Payment (as % of service exports) in Middle East & North Africa (developing only) in 2006 to that in 2010?
Keep it short and to the point. 1.06. What is the ratio of the Balance of Payment (as % of service exports) of Japan in 2006 to that in 2010?
Ensure brevity in your answer.  1.1. What is the ratio of the Balance of Payment (as % of service exports) in Saudi Arabia in 2006 to that in 2010?
Keep it short and to the point. 0.85. What is the ratio of the Balance of Payment (as % of service exports) of Fragile and conflict affected situations in 2006 to that in 2011?
Keep it short and to the point. 0.84. What is the ratio of the Balance of Payment (as % of service exports) of Middle East & North Africa (developing only) in 2006 to that in 2011?
Your answer should be compact. 0.9. What is the ratio of the Balance of Payment (as % of service exports) in Japan in 2006 to that in 2011?
Ensure brevity in your answer.  1.16. What is the ratio of the Balance of Payment (as % of service exports) of Saudi Arabia in 2006 to that in 2011?
Your answer should be compact. 0.94. What is the ratio of the Balance of Payment (as % of service exports) of Fragile and conflict affected situations in 2007 to that in 2008?
Your answer should be compact. 1.02. What is the ratio of the Balance of Payment (as % of service exports) in Middle East & North Africa (developing only) in 2007 to that in 2008?
Offer a terse response. 1.01. What is the ratio of the Balance of Payment (as % of service exports) in Japan in 2007 to that in 2008?
Your answer should be very brief. 1.04. What is the ratio of the Balance of Payment (as % of service exports) of Saudi Arabia in 2007 to that in 2008?
Your answer should be compact. 0.54. What is the ratio of the Balance of Payment (as % of service exports) in Fragile and conflict affected situations in 2007 to that in 2009?
Offer a very short reply. 1.16. What is the ratio of the Balance of Payment (as % of service exports) in Middle East & North Africa (developing only) in 2007 to that in 2009?
Your response must be concise. 1.16. What is the ratio of the Balance of Payment (as % of service exports) in Japan in 2007 to that in 2009?
Your response must be concise. 1.32. What is the ratio of the Balance of Payment (as % of service exports) of Saudi Arabia in 2007 to that in 2009?
Keep it short and to the point. 0.69. What is the ratio of the Balance of Payment (as % of service exports) in Fragile and conflict affected situations in 2007 to that in 2010?
Your answer should be very brief. 0.95. What is the ratio of the Balance of Payment (as % of service exports) of Middle East & North Africa (developing only) in 2007 to that in 2010?
Keep it short and to the point. 1.08. What is the ratio of the Balance of Payment (as % of service exports) of Japan in 2007 to that in 2010?
Provide a succinct answer. 1.1. What is the ratio of the Balance of Payment (as % of service exports) of Saudi Arabia in 2007 to that in 2010?
Your answer should be compact. 0.72. What is the ratio of the Balance of Payment (as % of service exports) in Fragile and conflict affected situations in 2007 to that in 2011?
Your answer should be compact. 0.81. What is the ratio of the Balance of Payment (as % of service exports) in Middle East & North Africa (developing only) in 2007 to that in 2011?
Offer a very short reply. 0.92. What is the ratio of the Balance of Payment (as % of service exports) of Japan in 2007 to that in 2011?
Your answer should be very brief. 1.17. What is the ratio of the Balance of Payment (as % of service exports) of Saudi Arabia in 2007 to that in 2011?
Keep it short and to the point. 0.8. What is the ratio of the Balance of Payment (as % of service exports) of Fragile and conflict affected situations in 2008 to that in 2009?
Provide a short and direct response. 1.13. What is the ratio of the Balance of Payment (as % of service exports) of Middle East & North Africa (developing only) in 2008 to that in 2009?
Give a very brief answer. 1.15. What is the ratio of the Balance of Payment (as % of service exports) of Japan in 2008 to that in 2009?
Your answer should be very brief. 1.27. What is the ratio of the Balance of Payment (as % of service exports) in Saudi Arabia in 2008 to that in 2009?
Your answer should be compact. 1.28. What is the ratio of the Balance of Payment (as % of service exports) of Fragile and conflict affected situations in 2008 to that in 2010?
Offer a very short reply. 0.93. What is the ratio of the Balance of Payment (as % of service exports) of Middle East & North Africa (developing only) in 2008 to that in 2010?
Give a very brief answer. 1.07. What is the ratio of the Balance of Payment (as % of service exports) in Japan in 2008 to that in 2010?
Make the answer very short. 1.06. What is the ratio of the Balance of Payment (as % of service exports) in Saudi Arabia in 2008 to that in 2010?
Give a very brief answer. 1.34. What is the ratio of the Balance of Payment (as % of service exports) of Fragile and conflict affected situations in 2008 to that in 2011?
Your response must be concise. 0.79. What is the ratio of the Balance of Payment (as % of service exports) in Middle East & North Africa (developing only) in 2008 to that in 2011?
Offer a terse response. 0.91. What is the ratio of the Balance of Payment (as % of service exports) in Japan in 2008 to that in 2011?
Offer a terse response. 1.12. What is the ratio of the Balance of Payment (as % of service exports) of Saudi Arabia in 2008 to that in 2011?
Make the answer very short. 1.48. What is the ratio of the Balance of Payment (as % of service exports) in Fragile and conflict affected situations in 2009 to that in 2010?
Ensure brevity in your answer.  0.82. What is the ratio of the Balance of Payment (as % of service exports) in Middle East & North Africa (developing only) in 2009 to that in 2010?
Provide a short and direct response. 0.93. What is the ratio of the Balance of Payment (as % of service exports) in Japan in 2009 to that in 2010?
Your answer should be very brief. 0.83. What is the ratio of the Balance of Payment (as % of service exports) of Saudi Arabia in 2009 to that in 2010?
Keep it short and to the point. 1.04. What is the ratio of the Balance of Payment (as % of service exports) in Fragile and conflict affected situations in 2009 to that in 2011?
Offer a terse response. 0.7. What is the ratio of the Balance of Payment (as % of service exports) of Middle East & North Africa (developing only) in 2009 to that in 2011?
Your response must be concise. 0.79. What is the ratio of the Balance of Payment (as % of service exports) of Japan in 2009 to that in 2011?
Provide a short and direct response. 0.88. What is the ratio of the Balance of Payment (as % of service exports) in Saudi Arabia in 2009 to that in 2011?
Ensure brevity in your answer.  1.16. What is the ratio of the Balance of Payment (as % of service exports) in Fragile and conflict affected situations in 2010 to that in 2011?
Offer a very short reply. 0.85. What is the ratio of the Balance of Payment (as % of service exports) in Middle East & North Africa (developing only) in 2010 to that in 2011?
Keep it short and to the point. 0.85. What is the ratio of the Balance of Payment (as % of service exports) in Japan in 2010 to that in 2011?
Your answer should be very brief. 1.06. What is the ratio of the Balance of Payment (as % of service exports) of Saudi Arabia in 2010 to that in 2011?
Keep it short and to the point. 1.11. What is the difference between the highest and the second highest Balance of Payment (as % of service exports) of Fragile and conflict affected situations?
Ensure brevity in your answer.  1.69. What is the difference between the highest and the second highest Balance of Payment (as % of service exports) of Middle East & North Africa (developing only)?
Your response must be concise. 1.82. What is the difference between the highest and the second highest Balance of Payment (as % of service exports) in Japan?
Your answer should be compact. 0.13. What is the difference between the highest and the second highest Balance of Payment (as % of service exports) in Saudi Arabia?
Give a very brief answer. 5.59. What is the difference between the highest and the lowest Balance of Payment (as % of service exports) of Fragile and conflict affected situations?
Offer a terse response. 3.31. What is the difference between the highest and the lowest Balance of Payment (as % of service exports) of Middle East & North Africa (developing only)?
Provide a short and direct response. 4.63. What is the difference between the highest and the lowest Balance of Payment (as % of service exports) of Japan?
Keep it short and to the point. 8.42. What is the difference between the highest and the lowest Balance of Payment (as % of service exports) of Saudi Arabia?
Your response must be concise. 11.76. 